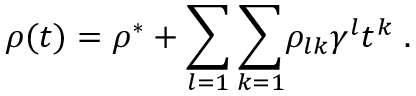<formula> <loc_0><loc_0><loc_500><loc_500>\rho ( t ) = \rho ^ { * } + { \sum _ { l = 1 } \sum _ { k = 1 } } \rho _ { l k } \gamma ^ { l } t ^ { k } \, .</formula> 